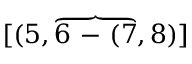<formula> <loc_0><loc_0><loc_500><loc_500>[ ( 5 , \overbrace { 6 - ( 7 } , 8 ) ]</formula> 